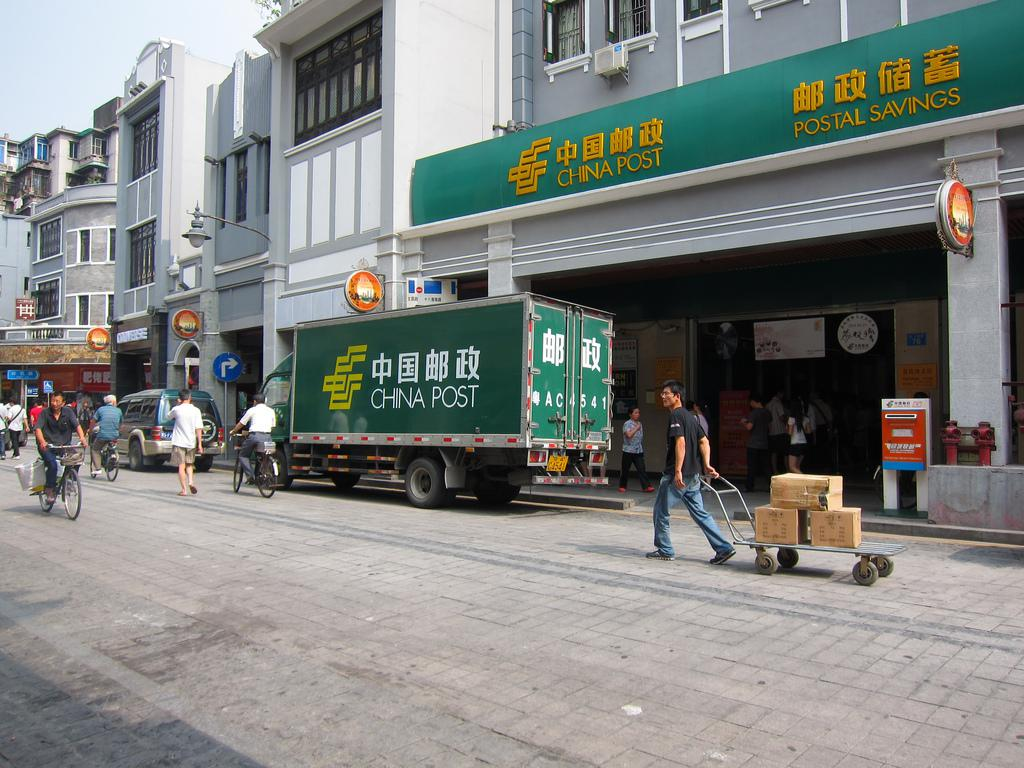Question: where is the sun?
Choices:
A. In the sky.
B. Behind the tree.
C. In the background.
D. Not in this picture.
Answer with the letter. Answer: D Question: what are the people riding as they pass the store?
Choices:
A. Motorcycles.
B. Bicycles.
C. Long boards.
D. Horses.
Answer with the letter. Answer: B Question: what is in the window above the china post sign?
Choices:
A. A poster.
B. A man.
C. Air conditioning unit.
D. A woman.
Answer with the letter. Answer: C Question: when will the man pulling the dolly get close to the truck?
Choices:
A. Soon, he's not too far away.
B. In a few minutes, he's a block away.
C. Very soon, he's just a few feet away.
D. In more than 5 minutes, he's several blocks away.
Answer with the letter. Answer: C Question: why does the man behind the truck, wearing a black shirt and jeans, need a dolly?
Choices:
A. He is pulling a friend on the dolly.
B. He is pulling cargo on the dolly.
C. He is loading boxes on the dolly.
D. He does not have a dolly.
Answer with the letter. Answer: B Question: how many items are on the dolly?
Choices:
A. Four.
B. Three.
C. One.
D. Sixteen.
Answer with the letter. Answer: B Question: what the number of big green trucks?
Choices:
A. Two.
B. One.
C. Four.
D. Six.
Answer with the letter. Answer: B Question: where are the three big packaged items?
Choices:
A. In the truck.
B. On the dolly that the man behind the truck,wearing a black top and jeans, is pulling.
C. Next to the dolly.
D. On the warehouse floor, waiting for the man behind the truck to load.
Answer with the letter. Answer: B Question: who are the people in the street?
Choices:
A. Police officers.
B. Rollerbladers.
C. Walkers and cyclists.
D. Dancers.
Answer with the letter. Answer: C Question: what is the color of the big truck?
Choices:
A. White.
B. Silver.
C. Green.
D. Black.
Answer with the letter. Answer: C Question: what are the boxes on?
Choices:
A. A cart.
B. A dolley.
C. A hand truck.
D. A pallet jack.
Answer with the letter. Answer: B Question: what color are most of the buildings?
Choices:
A. White.
B. Gray.
C. Red.
D. Brown.
Answer with the letter. Answer: B Question: what does the side of the truck say?
Choices:
A. U Haul.
B. Stater Bros.
C. Walmart.
D. China post.
Answer with the letter. Answer: D Question: how many orange round signs hang on front of the buildings?
Choices:
A. Five.
B. Three.
C. None.
D. Four.
Answer with the letter. Answer: D Question: how high are the buildings?
Choices:
A. 4 stories.
B. 3 stories.
C. 5 stories.
D. 6 stories.
Answer with the letter. Answer: B Question: who is pulling a dolly filled with boxes?
Choices:
A. A man.
B. A woman.
C. A worker.
D. A young person.
Answer with the letter. Answer: A Question: who carries the boxes on a dolly?
Choices:
A. A woman.
B. A boy.
C. A man.
D. A girl.
Answer with the letter. Answer: C Question: what does the green sign on the building state?
Choices:
A. Fresh n Easy.
B. Food 4 Less.
C. John Deere.
D. China post.
Answer with the letter. Answer: D Question: how many boxes are on the dolley?
Choices:
A. Two.
B. One.
C. None.
D. Three.
Answer with the letter. Answer: D 